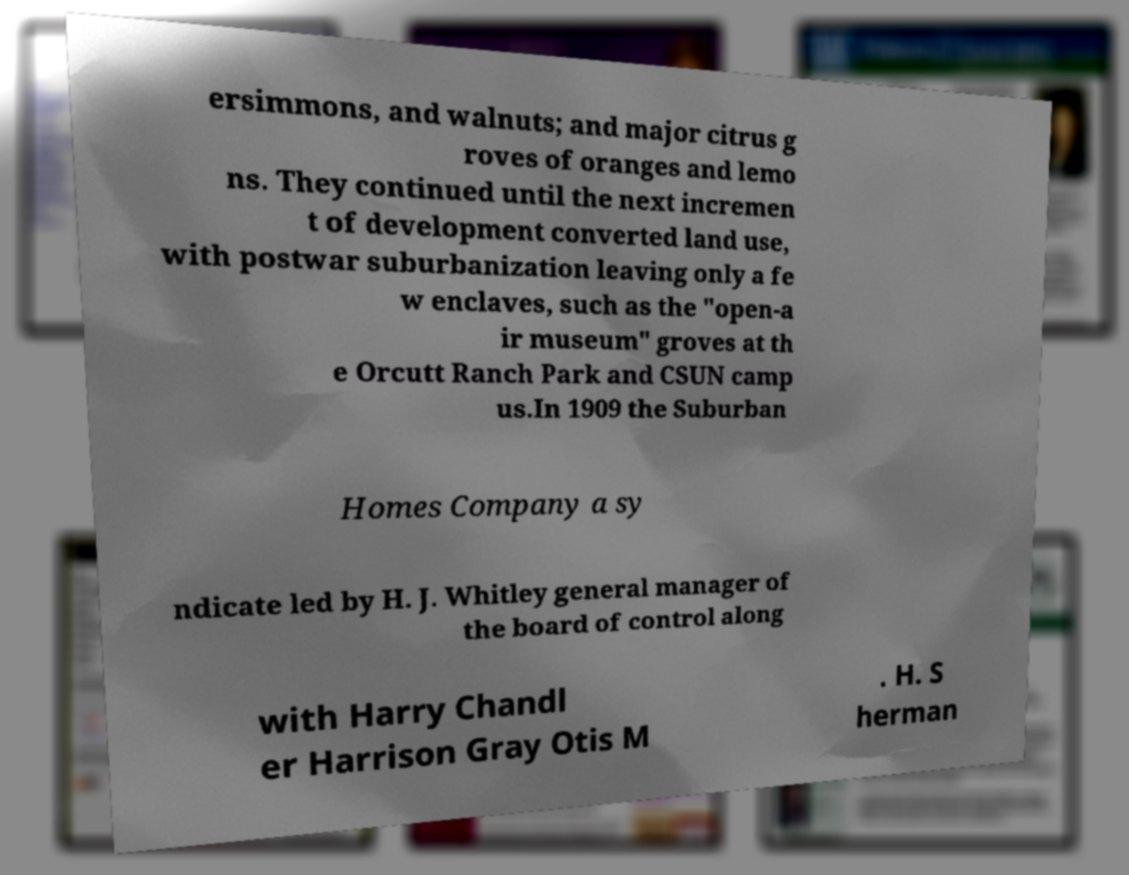Could you assist in decoding the text presented in this image and type it out clearly? ersimmons, and walnuts; and major citrus g roves of oranges and lemo ns. They continued until the next incremen t of development converted land use, with postwar suburbanization leaving only a fe w enclaves, such as the "open-a ir museum" groves at th e Orcutt Ranch Park and CSUN camp us.In 1909 the Suburban Homes Company a sy ndicate led by H. J. Whitley general manager of the board of control along with Harry Chandl er Harrison Gray Otis M . H. S herman 